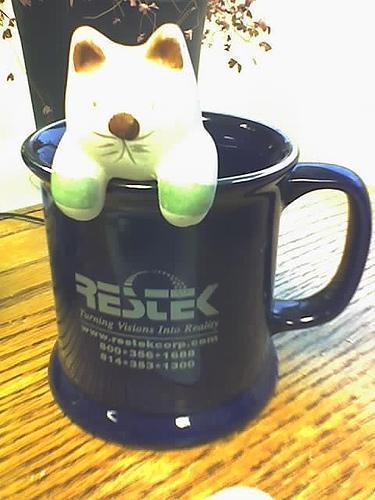Where is Restek's headquarters?
Choose the right answer from the provided options to respond to the question.
Options: California, florida, texas, utah. California. 